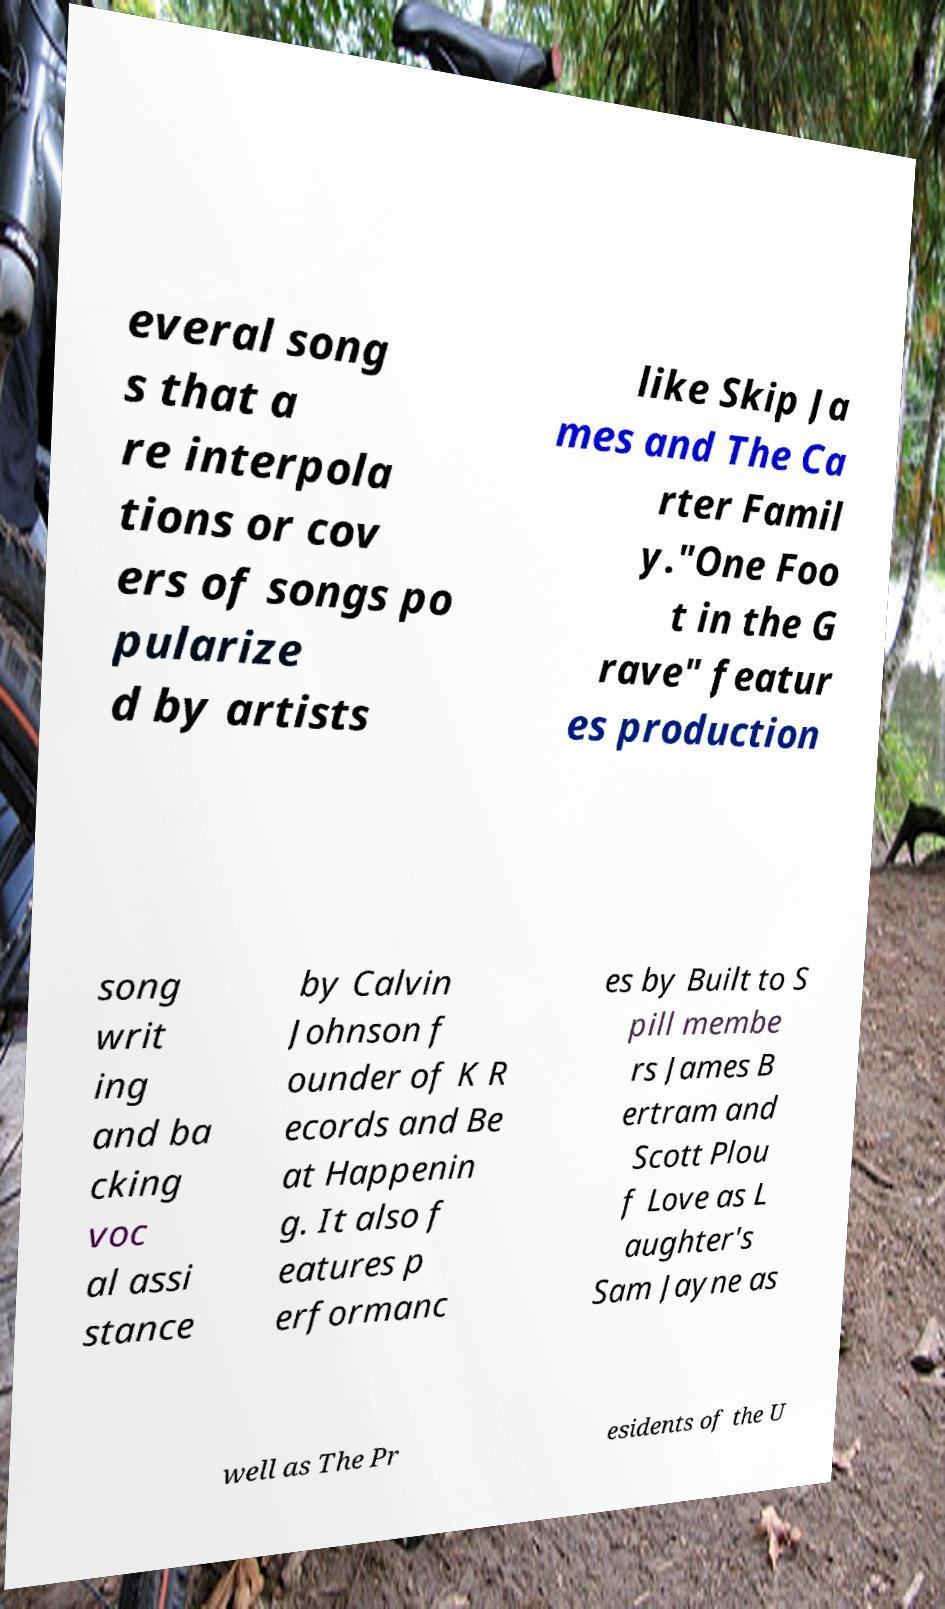Can you read and provide the text displayed in the image?This photo seems to have some interesting text. Can you extract and type it out for me? everal song s that a re interpola tions or cov ers of songs po pularize d by artists like Skip Ja mes and The Ca rter Famil y."One Foo t in the G rave" featur es production song writ ing and ba cking voc al assi stance by Calvin Johnson f ounder of K R ecords and Be at Happenin g. It also f eatures p erformanc es by Built to S pill membe rs James B ertram and Scott Plou f Love as L aughter's Sam Jayne as well as The Pr esidents of the U 